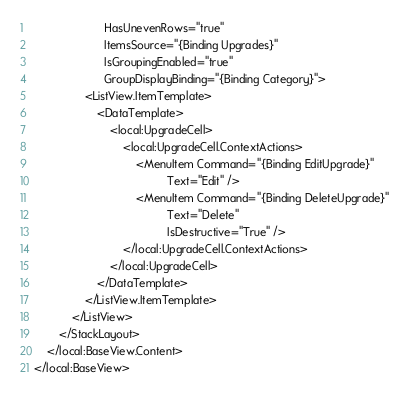<code> <loc_0><loc_0><loc_500><loc_500><_XML_>         			  HasUnevenRows="true"
					  ItemsSource="{Binding Upgrades}"
					  IsGroupingEnabled="true"
					  GroupDisplayBinding="{Binding Category}">
				<ListView.ItemTemplate>
					<DataTemplate> 
						<local:UpgradeCell>
							<local:UpgradeCell.ContextActions>
								<MenuItem Command="{Binding EditUpgrade}"
										  Text="Edit" />
								<MenuItem Command="{Binding DeleteUpgrade}"
					               		  Text="Delete" 
					               		  IsDestructive="True" />
							</local:UpgradeCell.ContextActions>
						</local:UpgradeCell>
					</DataTemplate>
				</ListView.ItemTemplate>
			</ListView>
		</StackLayout>
	</local:BaseView.Content>
</local:BaseView>
</code> 